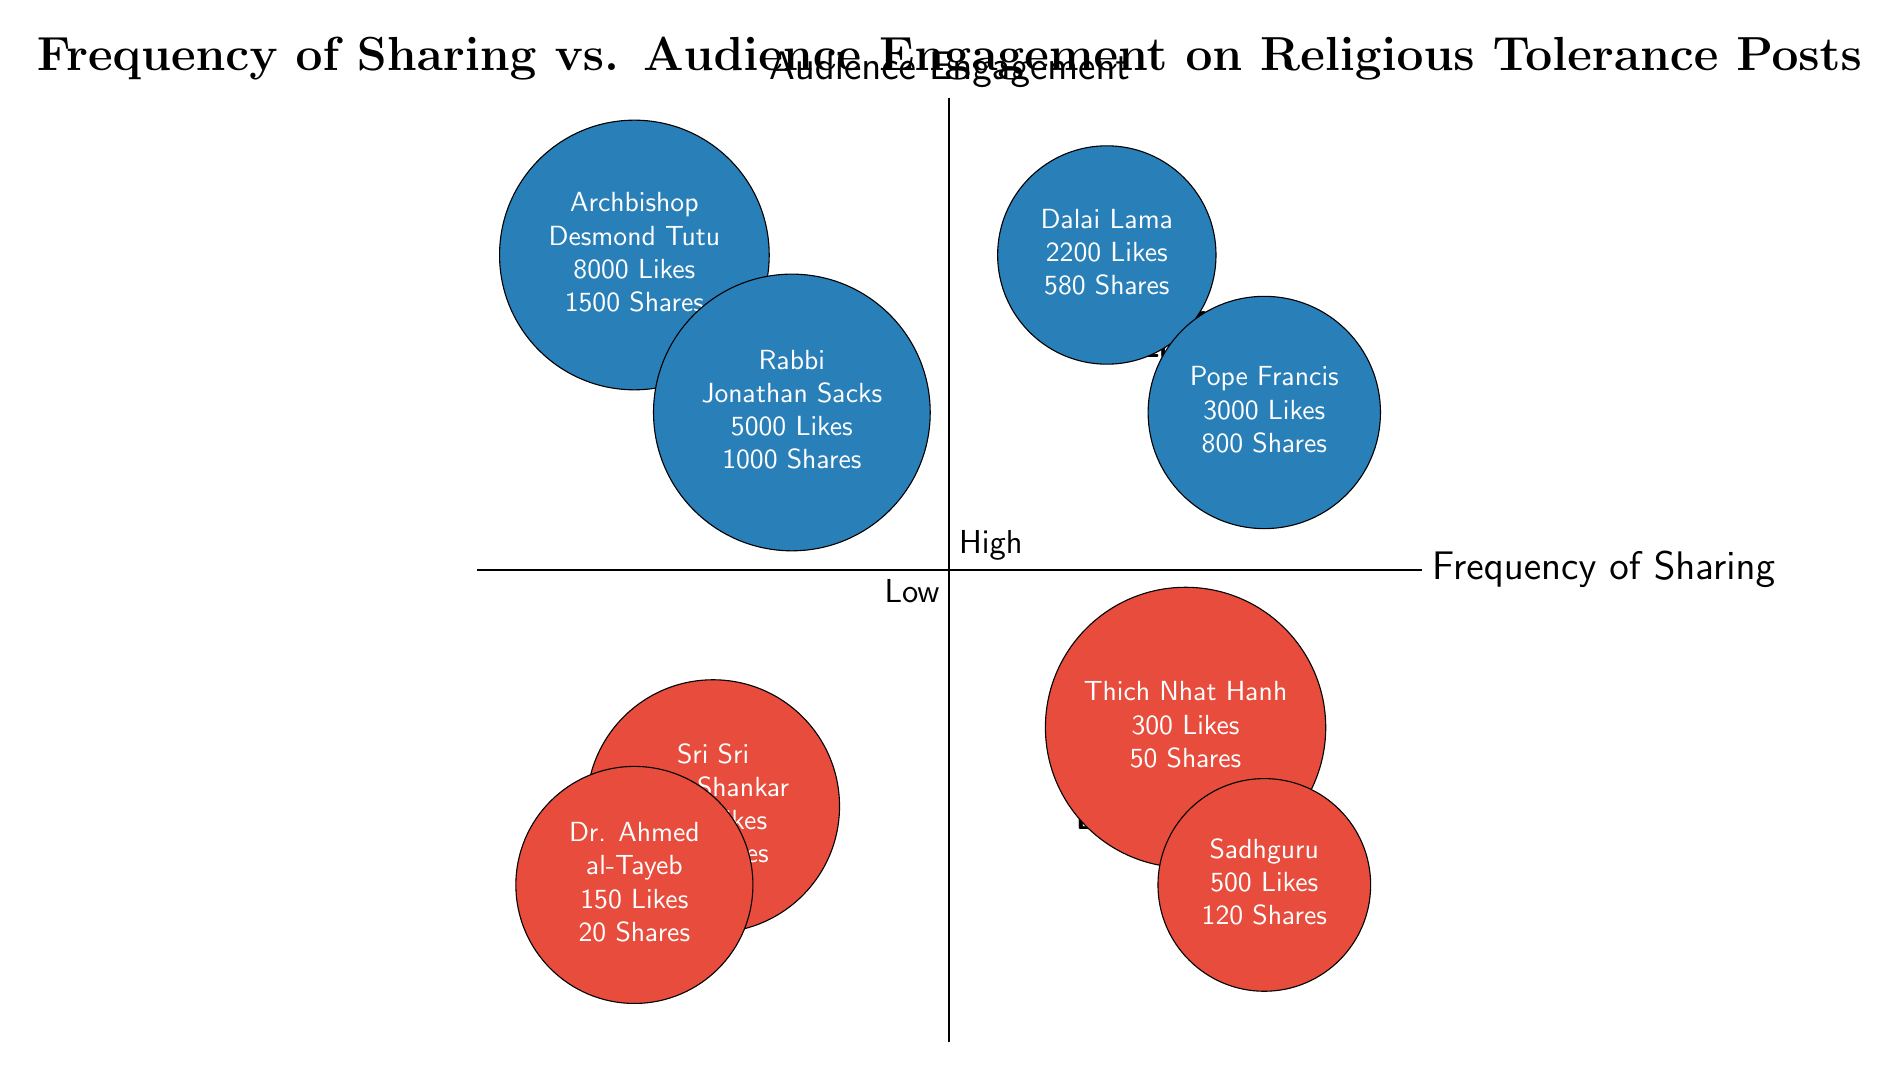What are the two posts with the highest likes? The posts with the highest likes can be found in the quadrant marked "High Frequency - High Engagement" and "Low Frequency - High Engagement." The first is "Understanding and Respecting Different Faiths" by Pope Francis with 3000 likes, and the second is "Annual Peace Message" by Archbishop Desmond Tutu with 8000 likes.
Answer: "Understanding and Respecting Different Faiths" and "Annual Peace Message" Which post has the lowest engagement metrics? Engagement metrics include likes, shares, and comments. Among all posts, "Words of Wisdom on Tolerance" by Dr. Ahmed al-Tayeb has the lowest engagement with 150 likes, 20 shares, and 10 comments, placing it in the "Low Frequency - Low Engagement" quadrant.
Answer: "Words of Wisdom on Tolerance" How many posts fall into the "High Frequency - High Engagement" quadrant? By examining the diagram, we can see that there are two entries: "Peaceful Coexistence Amidst Diversity" by Dalai Lama and "Understanding and Respecting Different Faiths" by Pope Francis. Therefore, there are two posts in this quadrant.
Answer: 2 Which leader has the post with the highest number of shares? In the diagram, "Annual Peace Message" by Archbishop Desmond Tutu has the highest number of shares at 1500, categorized in the "Low Frequency - High Engagement" quadrant.
Answer: Archbishop Desmond Tutu What is the total number of likes for the posts in the "Low Frequency - Low Engagement" quadrant? The posts in the "Low Frequency - Low Engagement" quadrant are "Thoughts on Universal Brotherhood" with 200 likes and "Words of Wisdom on Tolerance" with 150 likes. Summing these gives a total of 350 likes (200 + 150 = 350).
Answer: 350 Which quadrant contains posts with the highest audience engagement? The "Low Frequency - High Engagement" quadrant contains posts with the highest audience engagement metrics, including likes, shares, and comments. Notably, it includes posts such as "Annual Peace Message" by Archbishop Desmond Tutu.
Answer: Low Frequency - High Engagement What is the combined number of comments for posts in the "High Frequency - Low Engagement" quadrant? The posts "Weekly Reflections on Tolerance" by Thich Nhat Hanh and "Daily Quotes on Peace" by Sadhguru have 20 and 40 comments, respectively. Combining these gives a total of 60 comments: 20 + 40 = 60.
Answer: 60 Which post is categorized under "High Frequency - Low Engagement" and who is the leader? The posts in the "High Frequency - Low Engagement" quadrant include "Weekly Reflections on Tolerance" by Thich Nhat Hanh and "Daily Quotes on Peace" by Sadhguru, confirming that both posts are represented here.
Answer: "Weekly Reflections on Tolerance" by Thich Nhat Hanh and "Daily Quotes on Peace" by Sadhguru 